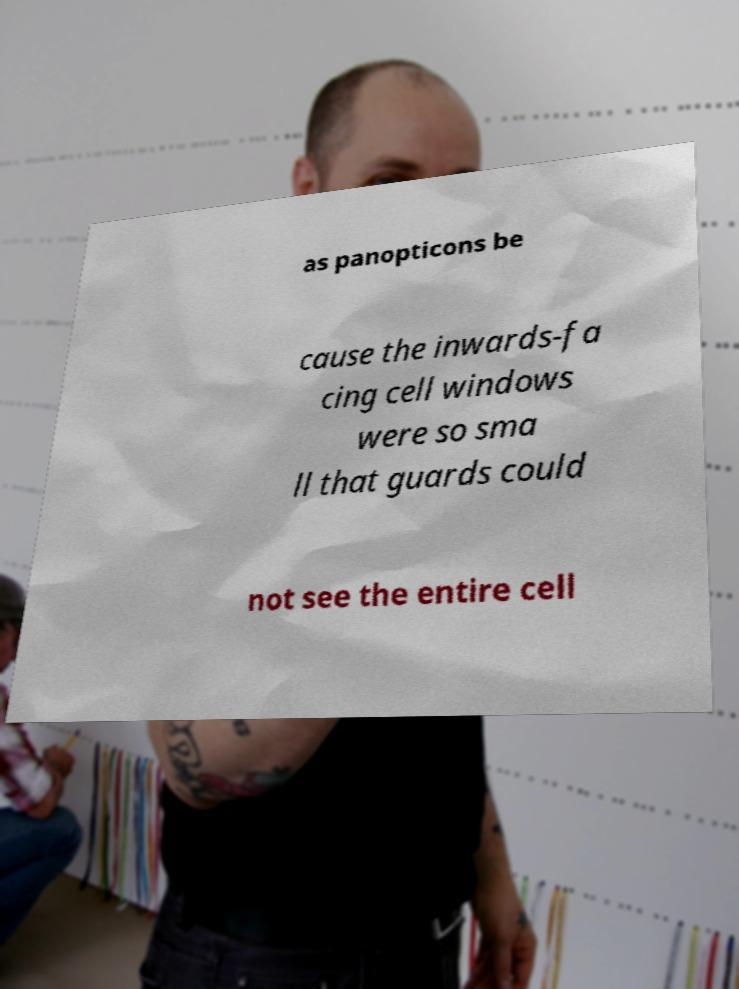For documentation purposes, I need the text within this image transcribed. Could you provide that? as panopticons be cause the inwards-fa cing cell windows were so sma ll that guards could not see the entire cell 